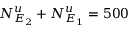Convert formula to latex. <formula><loc_0><loc_0><loc_500><loc_500>N _ { E _ { 2 } } ^ { u } + N _ { E _ { 1 } } ^ { u } = 5 0 0</formula> 